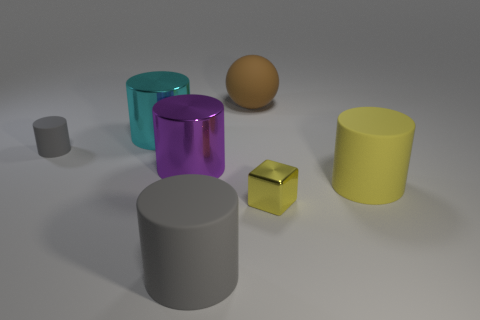What time of day does the lighting in the image suggest? The image seems to be lit with diffuse, neutral lighting which doesn't strongly suggest any particular time of day. It may be an indoor scene with artificial lighting. 